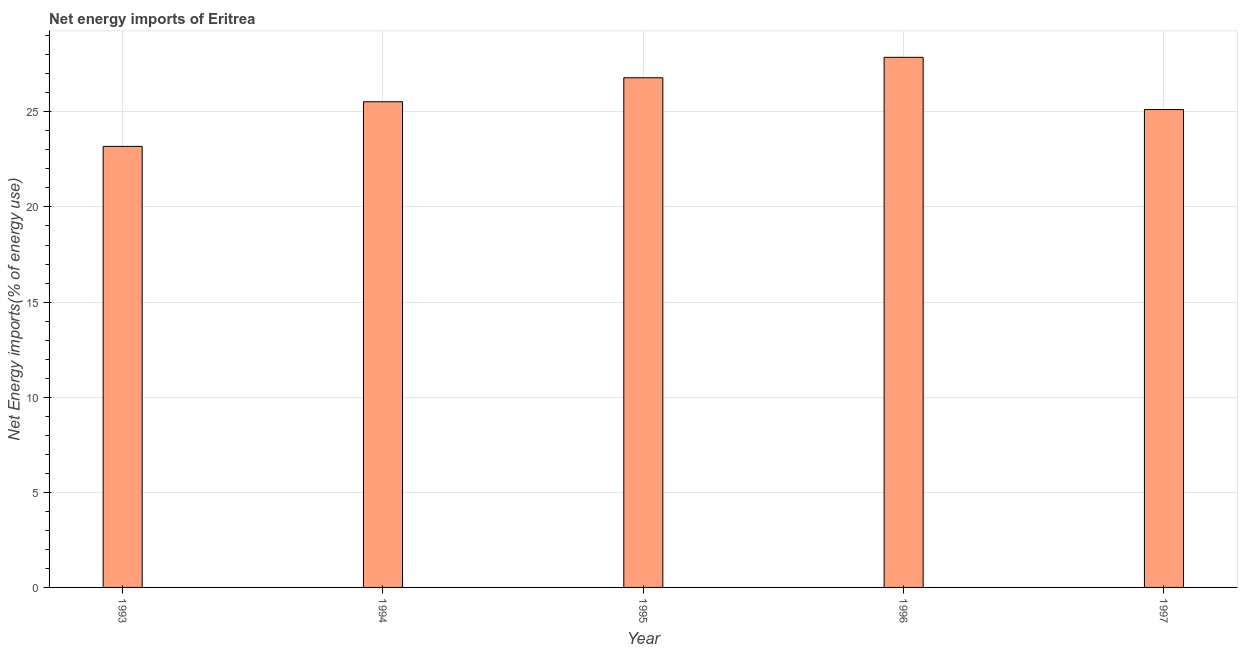Does the graph contain any zero values?
Provide a succinct answer. No. Does the graph contain grids?
Keep it short and to the point. Yes. What is the title of the graph?
Offer a very short reply. Net energy imports of Eritrea. What is the label or title of the X-axis?
Give a very brief answer. Year. What is the label or title of the Y-axis?
Your answer should be very brief. Net Energy imports(% of energy use). What is the energy imports in 1995?
Offer a very short reply. 26.79. Across all years, what is the maximum energy imports?
Ensure brevity in your answer.  27.87. Across all years, what is the minimum energy imports?
Offer a very short reply. 23.18. What is the sum of the energy imports?
Offer a very short reply. 128.5. What is the difference between the energy imports in 1993 and 1997?
Ensure brevity in your answer.  -1.94. What is the average energy imports per year?
Provide a short and direct response. 25.7. What is the median energy imports?
Provide a short and direct response. 25.53. In how many years, is the energy imports greater than 19 %?
Provide a succinct answer. 5. Do a majority of the years between 1994 and 1996 (inclusive) have energy imports greater than 14 %?
Make the answer very short. Yes. What is the ratio of the energy imports in 1994 to that in 1995?
Keep it short and to the point. 0.95. Is the difference between the energy imports in 1993 and 1994 greater than the difference between any two years?
Make the answer very short. No. What is the difference between the highest and the second highest energy imports?
Provide a succinct answer. 1.07. What is the difference between the highest and the lowest energy imports?
Ensure brevity in your answer.  4.68. Are all the bars in the graph horizontal?
Provide a short and direct response. No. How many years are there in the graph?
Make the answer very short. 5. What is the difference between two consecutive major ticks on the Y-axis?
Your answer should be very brief. 5. What is the Net Energy imports(% of energy use) in 1993?
Offer a terse response. 23.18. What is the Net Energy imports(% of energy use) in 1994?
Provide a succinct answer. 25.53. What is the Net Energy imports(% of energy use) in 1995?
Your answer should be very brief. 26.79. What is the Net Energy imports(% of energy use) of 1996?
Ensure brevity in your answer.  27.87. What is the Net Energy imports(% of energy use) of 1997?
Provide a succinct answer. 25.12. What is the difference between the Net Energy imports(% of energy use) in 1993 and 1994?
Provide a succinct answer. -2.35. What is the difference between the Net Energy imports(% of energy use) in 1993 and 1995?
Ensure brevity in your answer.  -3.61. What is the difference between the Net Energy imports(% of energy use) in 1993 and 1996?
Your answer should be compact. -4.68. What is the difference between the Net Energy imports(% of energy use) in 1993 and 1997?
Provide a succinct answer. -1.94. What is the difference between the Net Energy imports(% of energy use) in 1994 and 1995?
Ensure brevity in your answer.  -1.26. What is the difference between the Net Energy imports(% of energy use) in 1994 and 1996?
Give a very brief answer. -2.33. What is the difference between the Net Energy imports(% of energy use) in 1994 and 1997?
Provide a short and direct response. 0.41. What is the difference between the Net Energy imports(% of energy use) in 1995 and 1996?
Your answer should be compact. -1.07. What is the difference between the Net Energy imports(% of energy use) in 1995 and 1997?
Offer a very short reply. 1.67. What is the difference between the Net Energy imports(% of energy use) in 1996 and 1997?
Your answer should be compact. 2.74. What is the ratio of the Net Energy imports(% of energy use) in 1993 to that in 1994?
Give a very brief answer. 0.91. What is the ratio of the Net Energy imports(% of energy use) in 1993 to that in 1995?
Provide a succinct answer. 0.86. What is the ratio of the Net Energy imports(% of energy use) in 1993 to that in 1996?
Keep it short and to the point. 0.83. What is the ratio of the Net Energy imports(% of energy use) in 1993 to that in 1997?
Your response must be concise. 0.92. What is the ratio of the Net Energy imports(% of energy use) in 1994 to that in 1995?
Provide a succinct answer. 0.95. What is the ratio of the Net Energy imports(% of energy use) in 1994 to that in 1996?
Ensure brevity in your answer.  0.92. What is the ratio of the Net Energy imports(% of energy use) in 1995 to that in 1996?
Provide a short and direct response. 0.96. What is the ratio of the Net Energy imports(% of energy use) in 1995 to that in 1997?
Make the answer very short. 1.07. What is the ratio of the Net Energy imports(% of energy use) in 1996 to that in 1997?
Offer a terse response. 1.11. 